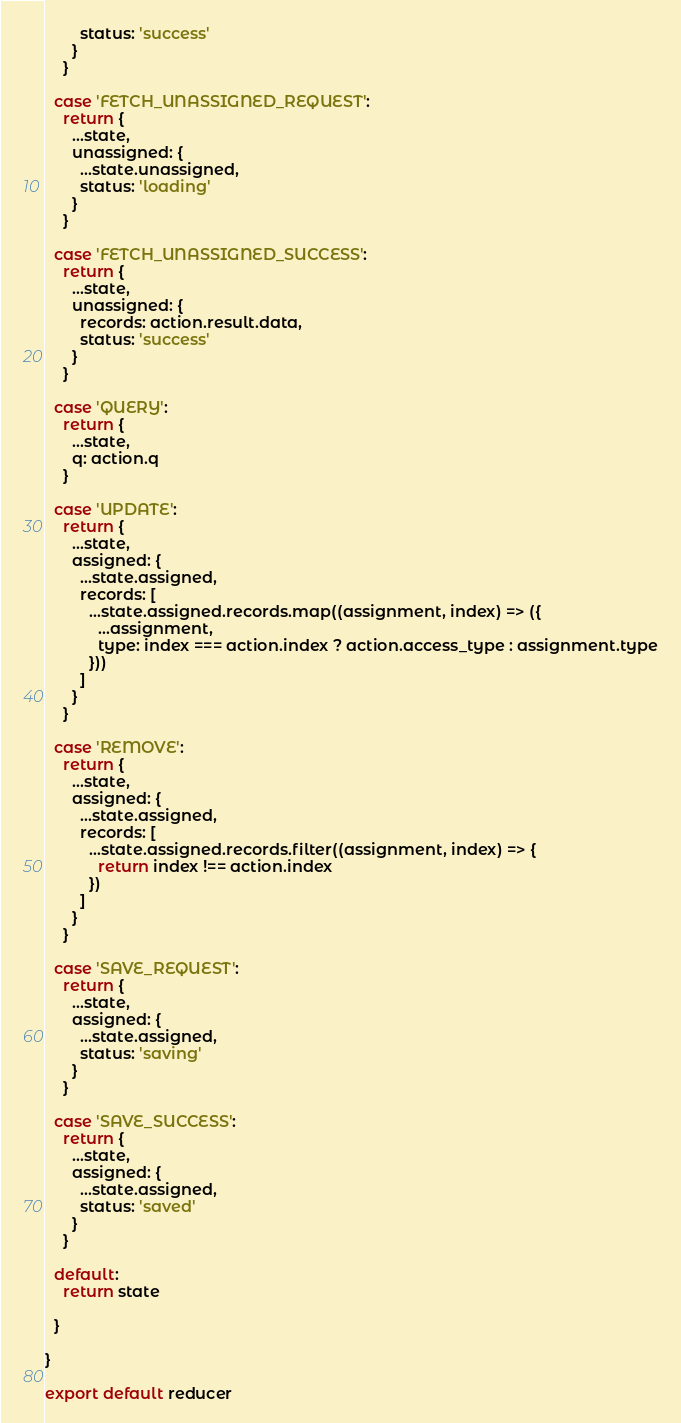Convert code to text. <code><loc_0><loc_0><loc_500><loc_500><_JavaScript_>        status: 'success'
      }
    }

  case 'FETCH_UNASSIGNED_REQUEST':
    return {
      ...state,
      unassigned: {
        ...state.unassigned,
        status: 'loading'
      }
    }

  case 'FETCH_UNASSIGNED_SUCCESS':
    return {
      ...state,
      unassigned: {
        records: action.result.data,
        status: 'success'
      }
    }

  case 'QUERY':
    return {
      ...state,
      q: action.q
    }

  case 'UPDATE':
    return {
      ...state,
      assigned: {
        ...state.assigned,
        records: [
          ...state.assigned.records.map((assignment, index) => ({
            ...assignment,
            type: index === action.index ? action.access_type : assignment.type
          }))
        ]
      }
    }

  case 'REMOVE':
    return {
      ...state,
      assigned: {
        ...state.assigned,
        records: [
          ...state.assigned.records.filter((assignment, index) => {
            return index !== action.index
          })
        ]
      }
    }

  case 'SAVE_REQUEST':
    return {
      ...state,
      assigned: {
        ...state.assigned,
        status: 'saving'
      }
    }

  case 'SAVE_SUCCESS':
    return {
      ...state,
      assigned: {
        ...state.assigned,
        status: 'saved'
      }
    }

  default:
    return state

  }

}

export default reducer
</code> 